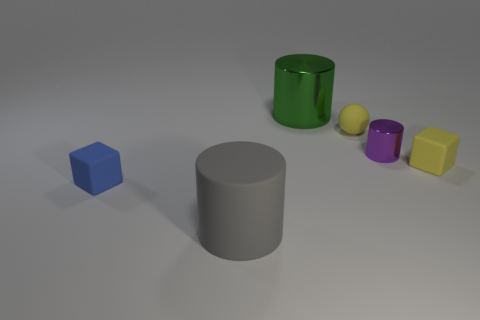Do the purple object and the small ball have the same material?
Offer a terse response. No. There is a cube that is behind the small matte cube that is on the left side of the yellow matte cube; how many things are in front of it?
Offer a terse response. 2. The large cylinder that is in front of the big metallic cylinder is what color?
Your answer should be very brief. Gray. What is the shape of the tiny yellow object that is behind the small yellow thing in front of the yellow matte ball?
Your answer should be compact. Sphere. How many cylinders are blue metal things or large gray things?
Offer a very short reply. 1. What material is the thing that is in front of the large green thing and behind the purple cylinder?
Your answer should be compact. Rubber. There is a large matte object; how many tiny yellow balls are behind it?
Offer a terse response. 1. Is the material of the cylinder that is in front of the blue rubber object the same as the cylinder on the right side of the green thing?
Keep it short and to the point. No. How many objects are either tiny yellow rubber objects that are in front of the small sphere or yellow cylinders?
Provide a succinct answer. 1. Is the number of tiny yellow matte balls that are behind the tiny metallic cylinder less than the number of large cylinders left of the rubber ball?
Give a very brief answer. Yes. 